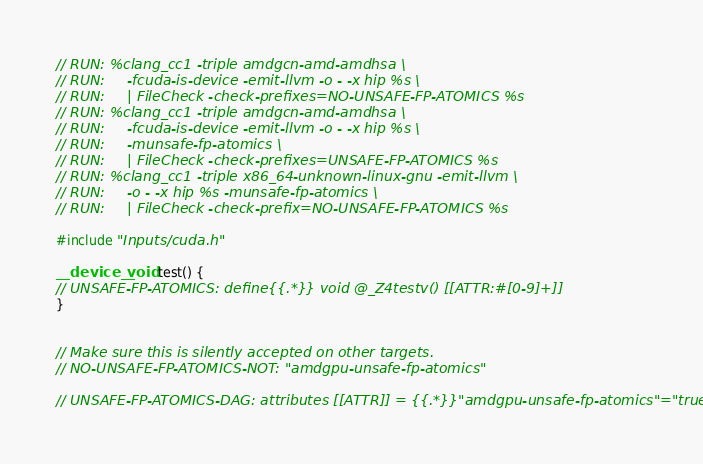<code> <loc_0><loc_0><loc_500><loc_500><_Cuda_>// RUN: %clang_cc1 -triple amdgcn-amd-amdhsa \
// RUN:     -fcuda-is-device -emit-llvm -o - -x hip %s \
// RUN:     | FileCheck -check-prefixes=NO-UNSAFE-FP-ATOMICS %s
// RUN: %clang_cc1 -triple amdgcn-amd-amdhsa \
// RUN:     -fcuda-is-device -emit-llvm -o - -x hip %s \
// RUN:     -munsafe-fp-atomics \
// RUN:     | FileCheck -check-prefixes=UNSAFE-FP-ATOMICS %s
// RUN: %clang_cc1 -triple x86_64-unknown-linux-gnu -emit-llvm \
// RUN:     -o - -x hip %s -munsafe-fp-atomics \
// RUN:     | FileCheck -check-prefix=NO-UNSAFE-FP-ATOMICS %s

#include "Inputs/cuda.h"

__device__ void test() {
// UNSAFE-FP-ATOMICS: define{{.*}} void @_Z4testv() [[ATTR:#[0-9]+]]
}


// Make sure this is silently accepted on other targets.
// NO-UNSAFE-FP-ATOMICS-NOT: "amdgpu-unsafe-fp-atomics"

// UNSAFE-FP-ATOMICS-DAG: attributes [[ATTR]] = {{.*}}"amdgpu-unsafe-fp-atomics"="true"
</code> 